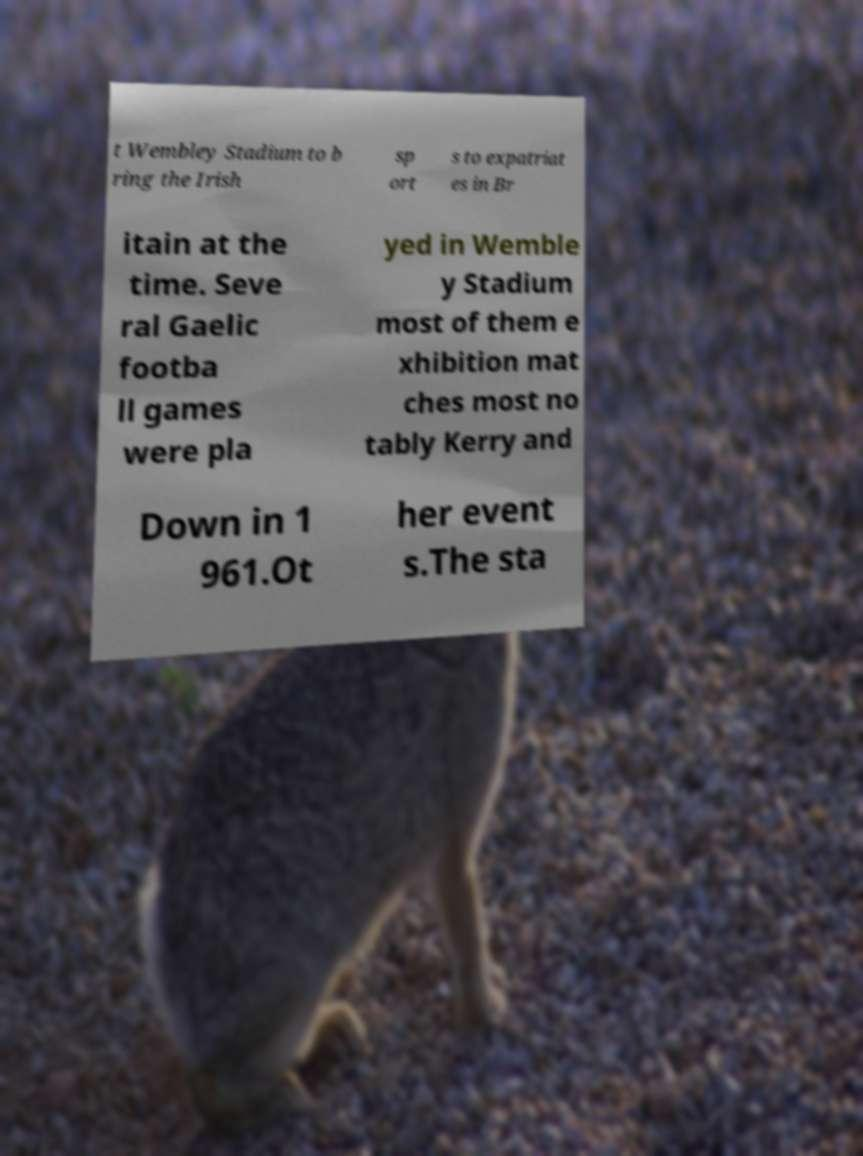There's text embedded in this image that I need extracted. Can you transcribe it verbatim? t Wembley Stadium to b ring the Irish sp ort s to expatriat es in Br itain at the time. Seve ral Gaelic footba ll games were pla yed in Wemble y Stadium most of them e xhibition mat ches most no tably Kerry and Down in 1 961.Ot her event s.The sta 